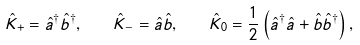Convert formula to latex. <formula><loc_0><loc_0><loc_500><loc_500>\hat { K } _ { + } = \hat { a } ^ { \dag } \hat { b } ^ { \dag } , \quad \hat { K } _ { - } = \hat { a } \hat { b } , \quad \hat { K } _ { 0 } = \frac { 1 } { 2 } \left ( \hat { a } ^ { \dag } \hat { a } + \hat { b } \hat { b } ^ { \dag } \right ) ,</formula> 